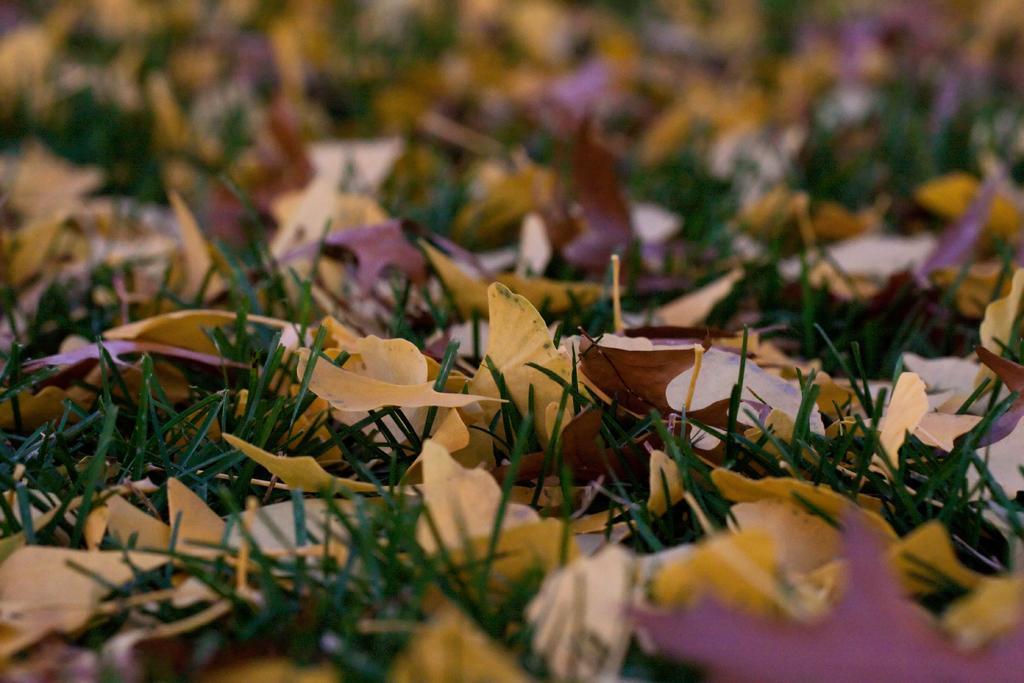Could you give a brief overview of what you see in this image? In this image we can see the dry leaves on the grass and this part of the image is blurred. 